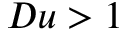Convert formula to latex. <formula><loc_0><loc_0><loc_500><loc_500>D u > 1</formula> 